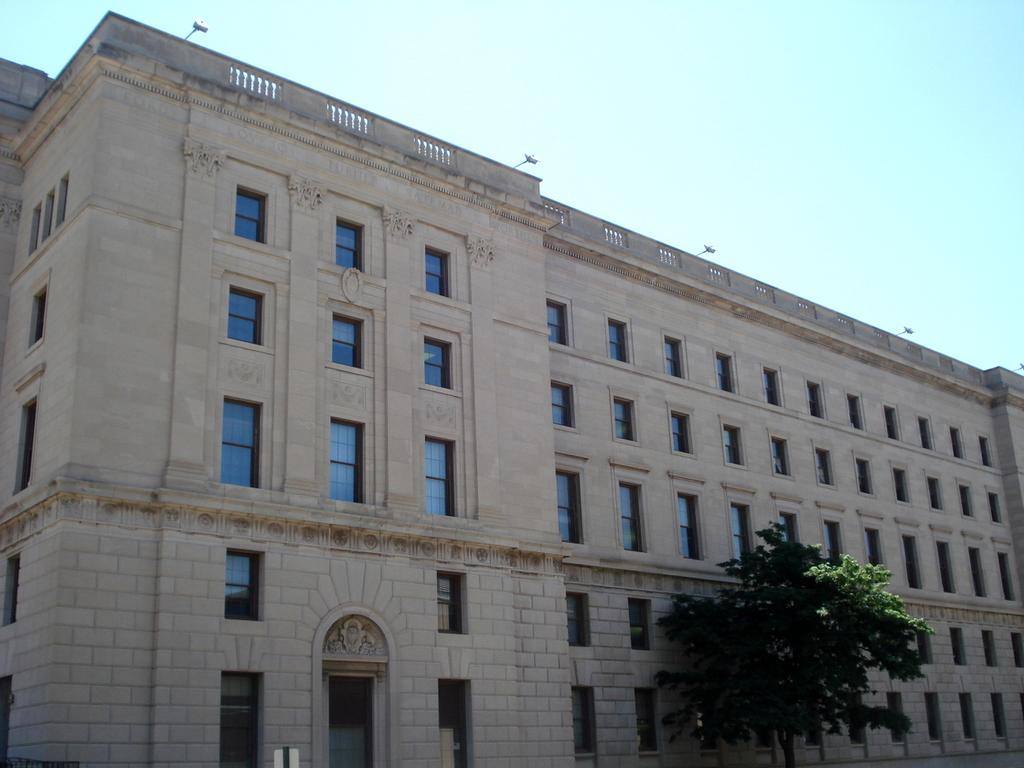What type of structure is present in the image? There is a building in the image. What features can be observed on the building? The building has windows and a door. What other object is present in the image? There is a tree in the image. What is visible at the top of the image? The sky is visible at the top of the image. What color is the skin of the tree in the image? There is no mention of skin in the image, as trees do not have skin. The tree in the image is likely made up of bark and leaves. 